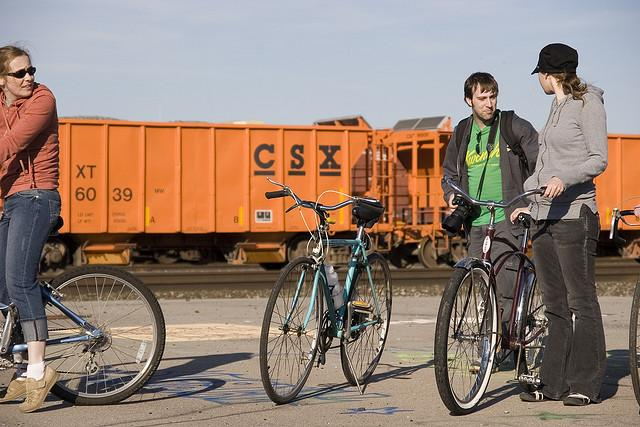How many motors are on the vehicles used by the people shown here to get them here? zero 